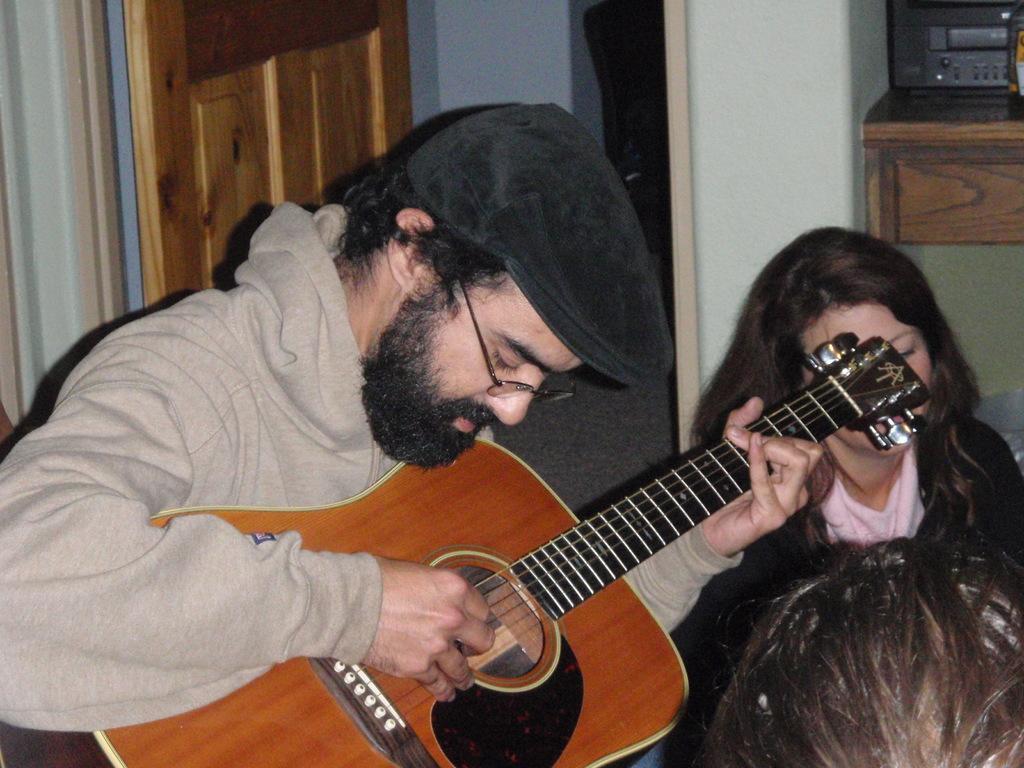Can you describe this image briefly? In the image we can see there is a person who is sitting and holding guitar in his hand and beside him there are women who are sitting on the floor and the man is wearing black colour cap. 